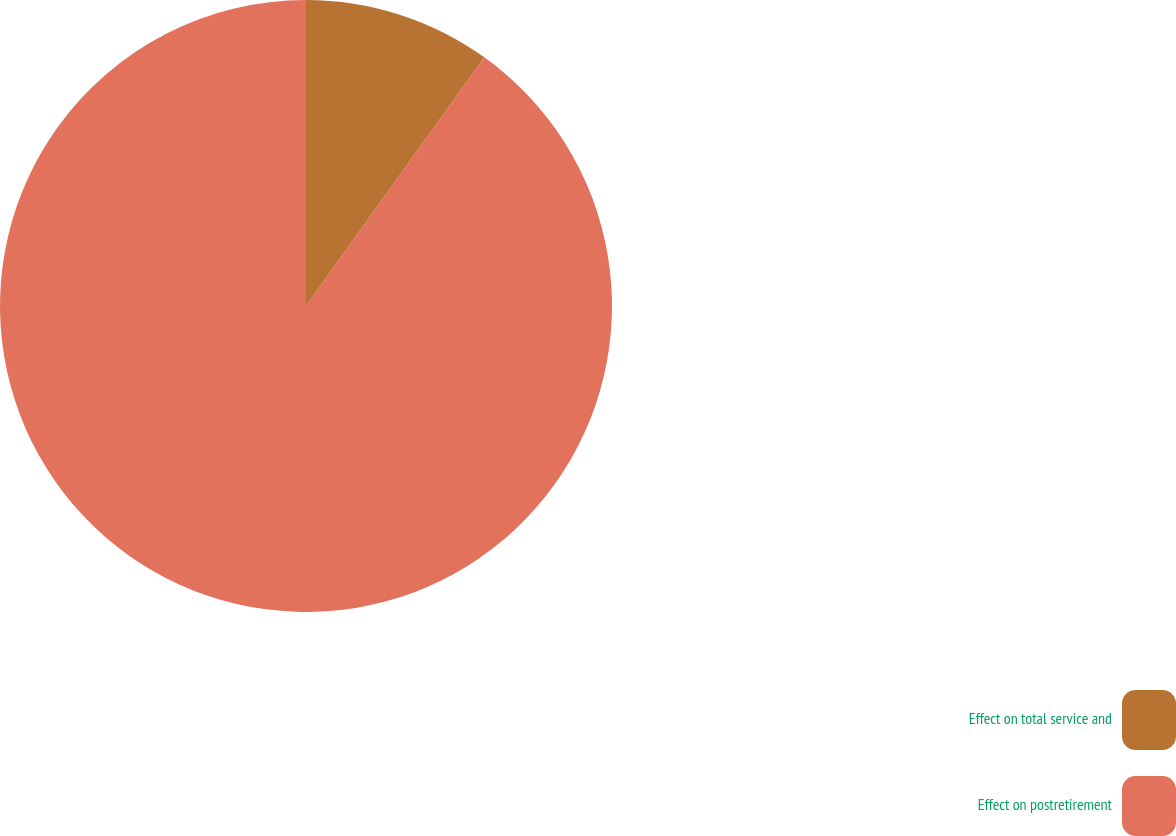<chart> <loc_0><loc_0><loc_500><loc_500><pie_chart><fcel>Effect on total service and<fcel>Effect on postretirement<nl><fcel>9.9%<fcel>90.1%<nl></chart> 